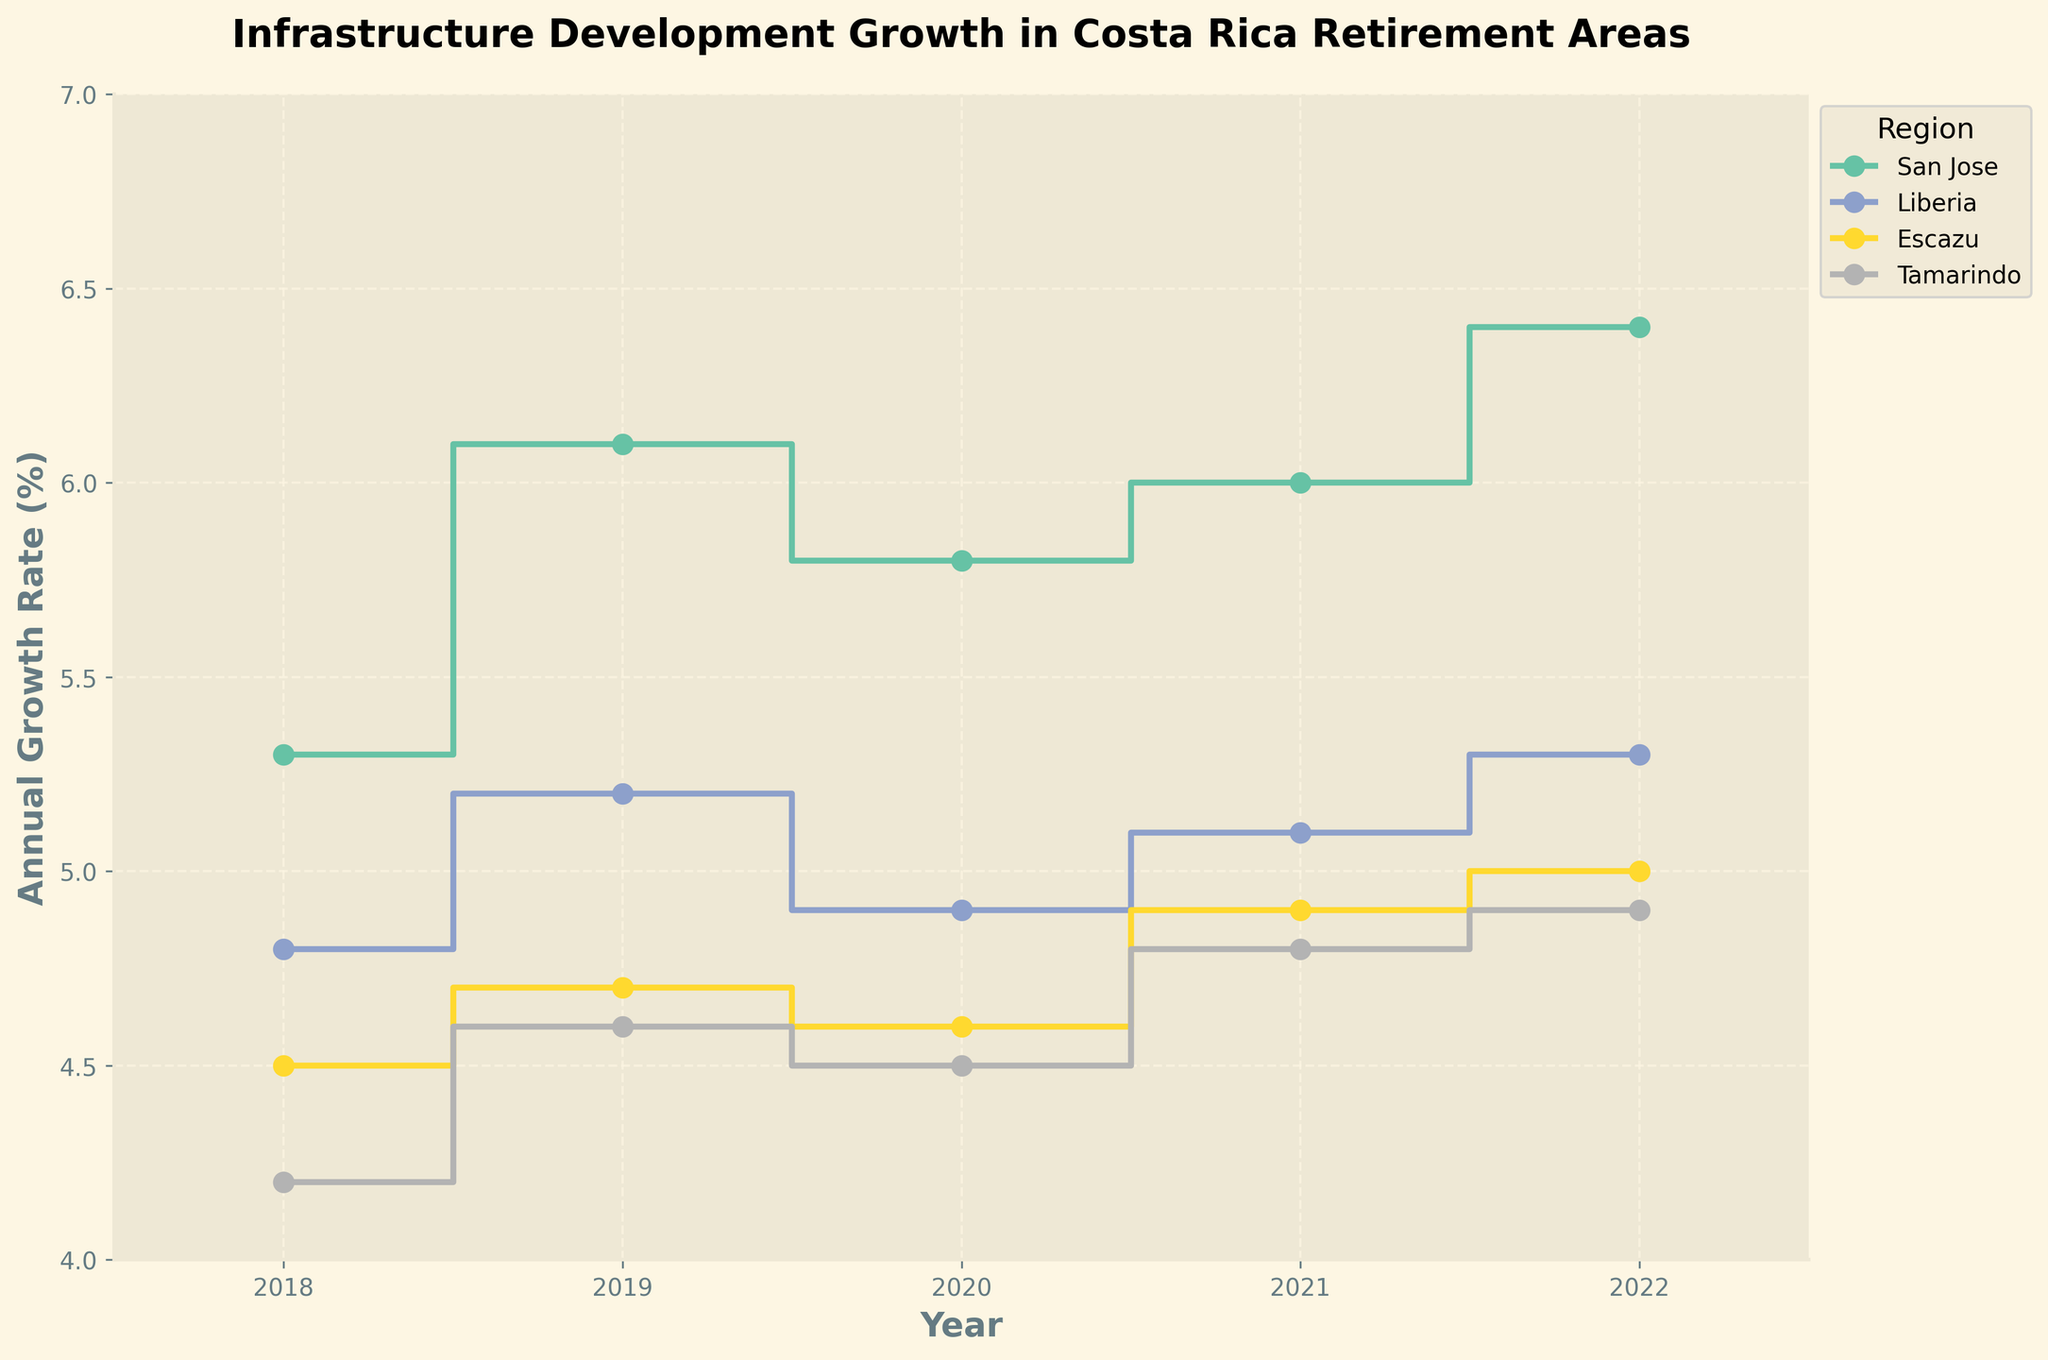What is the title of the figure? The title of the figure is usually displayed at the top and summarizes the content it represents. In this figure, the title focuses on the infrastructural growth in Costa Rica's retirement areas.
Answer: Infrastructure Development Growth in Costa Rica Retirement Areas How many regions are displayed in the figure? To identify the regions, look at the legend on the right of the figure, where all regions represented by different colored lines are listed.
Answer: Four Which region had the highest annual growth rate in 2022? By identifying the year 2022 on the x-axis and tracing upwards, we can see which region reaches the highest point on the y-axis for that year.
Answer: San Jose What was the average annual growth rate for Liberia between 2018 and 2022? First, find the annual growth rates for Liberia between 2018 and 2022, which are 4.8, 5.2, 4.9, 5.1, and 5.3. Sum these rates and divide by the number of years to get the average. (4.8 + 5.2 + 4.9 + 5.1 + 5.3) / 5 = 25.3 / 5
Answer: 5.06 Which year showed the highest growth rate for Escazu? By tracing the Escazu line from 2018 to 2022, observe which point is the highest.
Answer: 2022 How does the annual growth rate for Tamarindo compare between 2018 and 2022? To compare, find the values for Tamarindo for the years 2018 and 2022 and calculate the difference. Tamarindo's values are 4.2 in 2018 and 4.9 in 2022. Thus, 4.9 - 4.2 = 0.7, indicating an increase.
Answer: Increased by 0.7 Which region showed the most consistent annual growth rate from 2018 to 2022? A consistent annual growth rate implies minimal fluctuation over the years. By observing the smoothness and evenness of the lines, compare which region has the least variation. Escazu's line appears to have the least variation.
Answer: Escazu Did any region experience a decrease in the annual growth rate between any two consecutive years? To determine if any decrease occurred, examine the lines for each region year by year to check for any downward steps. Liberia shows a decrease from 2019 to 2020 (5.2 to 4.9).
Answer: Yes, Liberia from 2019 to 2020 What is the range of the annual growth rate for San Jose from 2018 to 2022? To find the range, identify the highest and lowest values of the annual growth rate for San Jose over the given years. The highest value is 6.4 in 2022 and the lowest is 5.3 in 2018. The range is 6.4 - 5.3.
Answer: 1.1 Which region had the steepest increase in annual growth rate in any single year? Steepest increase refers to the largest vertical step change between consecutive years. By closely observing the lines, San Jose had the steepest increase from 2018 to 2019 (5.3 to 6.1).
Answer: San Jose from 2018 to 2019 